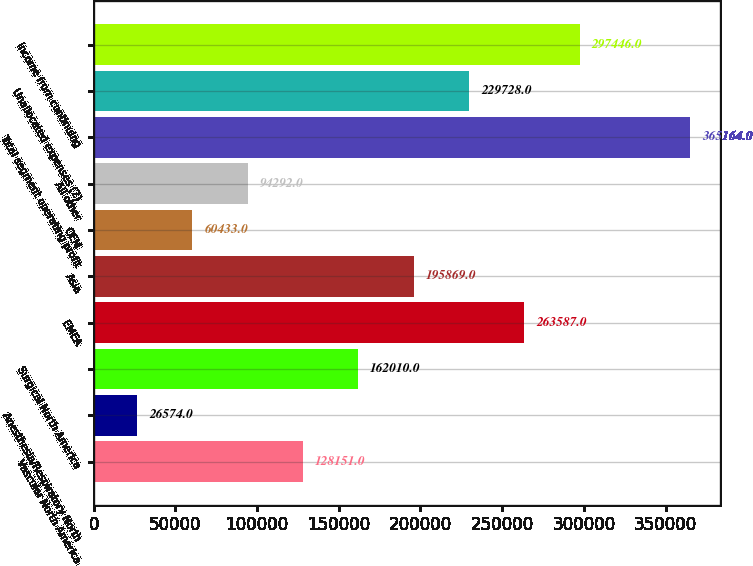Convert chart. <chart><loc_0><loc_0><loc_500><loc_500><bar_chart><fcel>Vascular North America<fcel>Anesthesia/Respiratory North<fcel>Surgical North America<fcel>EMEA<fcel>Asia<fcel>OEM<fcel>All other<fcel>Total segment operating profit<fcel>Unallocated expenses (2)<fcel>Income from continuing<nl><fcel>128151<fcel>26574<fcel>162010<fcel>263587<fcel>195869<fcel>60433<fcel>94292<fcel>365164<fcel>229728<fcel>297446<nl></chart> 